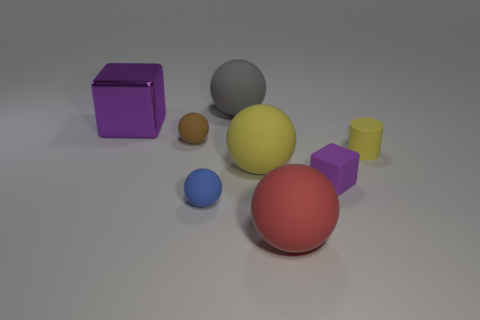Do the purple block behind the yellow sphere and the yellow rubber object that is in front of the yellow cylinder have the same size?
Give a very brief answer. Yes. How many other things are the same size as the gray thing?
Offer a terse response. 3. Is there a big yellow sphere that is in front of the purple thing that is left of the big matte ball in front of the tiny blue object?
Make the answer very short. Yes. What is the size of the purple block in front of the brown thing?
Provide a short and direct response. Small. There is a ball behind the purple cube to the left of the gray object that is behind the red sphere; how big is it?
Provide a succinct answer. Large. What color is the cube right of the big sphere that is right of the big yellow object?
Provide a succinct answer. Purple. There is another big purple object that is the same shape as the purple matte object; what is its material?
Your answer should be compact. Metal. Are there any other things that have the same material as the big purple object?
Offer a terse response. No. There is a big cube; are there any red things in front of it?
Ensure brevity in your answer.  Yes. What number of spheres are there?
Provide a short and direct response. 5. 